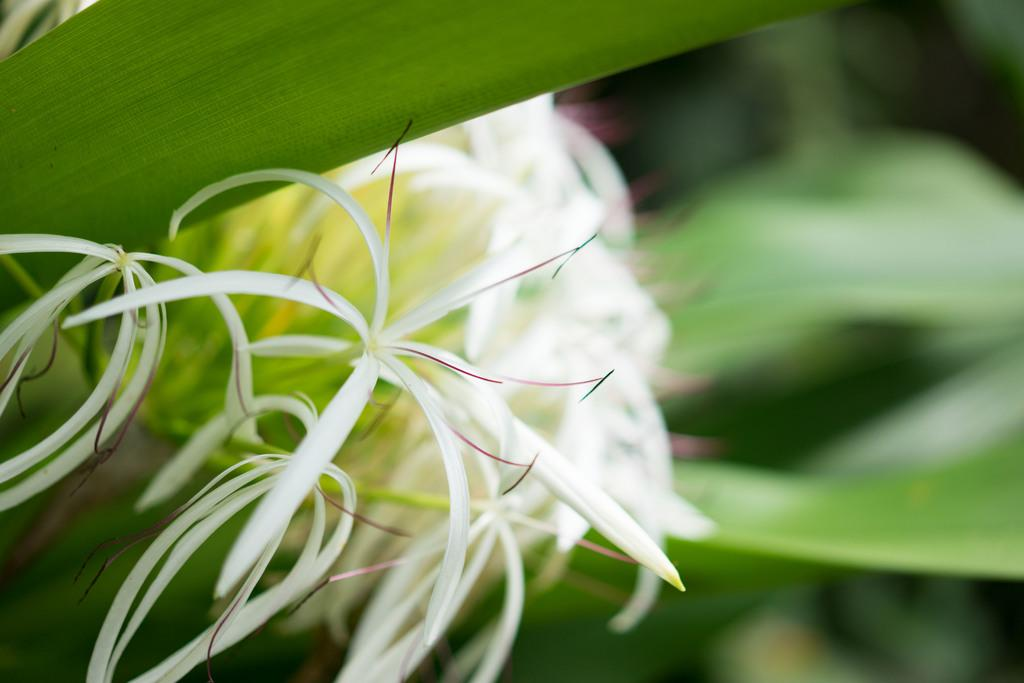What type of plants can be seen in the image? There are flowers and leaves in the image. Can you describe the background of the image? The background of the image is blurry. What type of door can be seen in the image? There is no door present in the image; it features flowers and leaves with a blurry background. What is the weather like in the image? The provided facts do not mention the weather, so it cannot be determined from the image. 